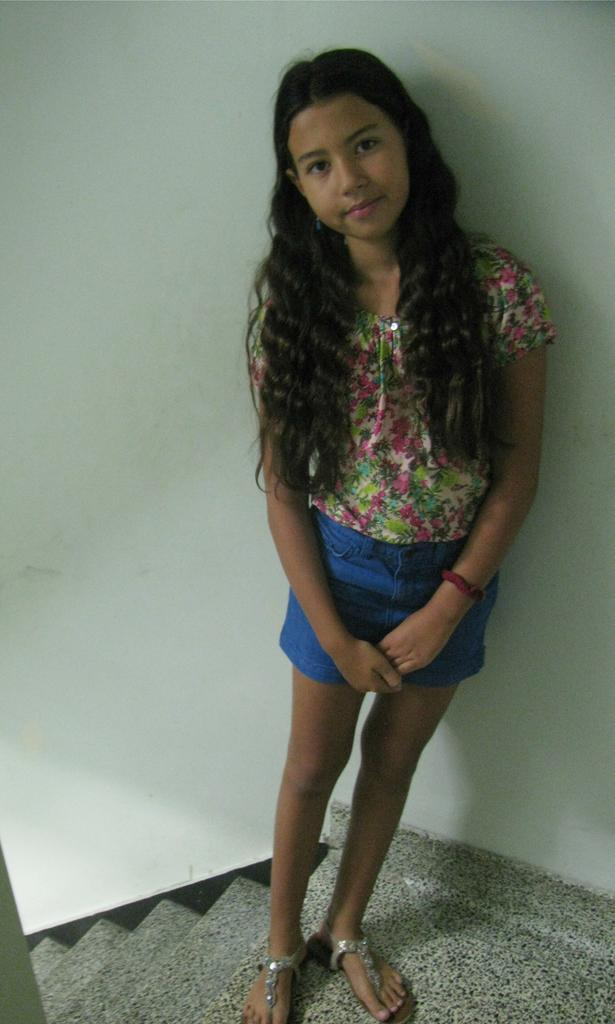Who is present in the image? There is a girl in the image. What is the girl doing in the image? The girl is standing on the floor and smiling. What architectural feature can be seen in the image? There are steps visible in the image. What is visible in the background of the image? There is a wall in the background of the image. What direction is the girl facing in the image? The direction the girl is facing cannot be determined from the image. What type of glass object is visible in the image? There is no glass object present in the image. 